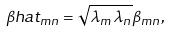<formula> <loc_0><loc_0><loc_500><loc_500>\beta h a t _ { m n } = \sqrt { \lambda _ { m } \lambda _ { n } } \beta _ { m n } ,</formula> 